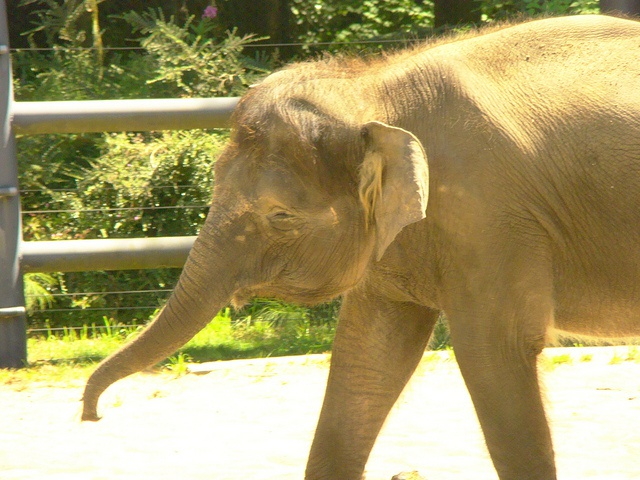Describe the objects in this image and their specific colors. I can see a elephant in gray, olive, and khaki tones in this image. 